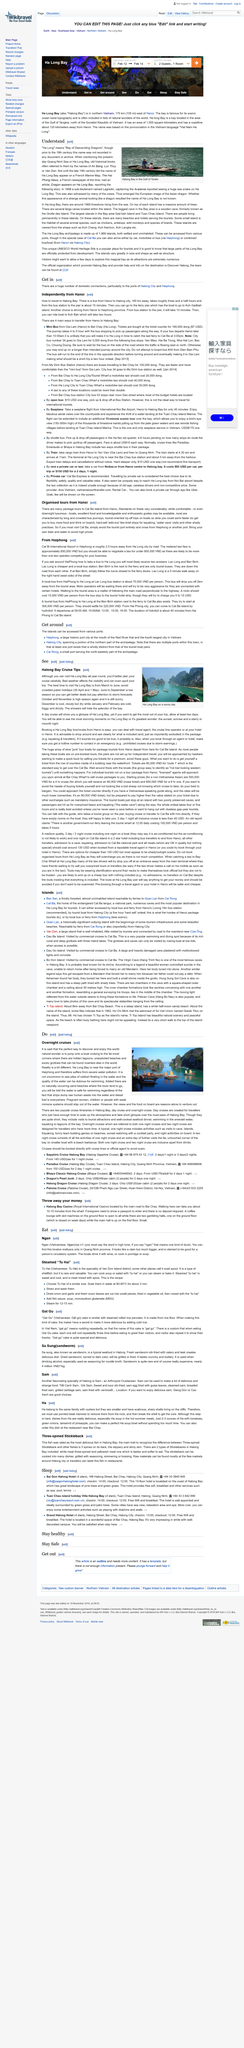Point out several critical features in this image. The top right image was taken in Halong Bay in the Gulf of Tonkin. Ha Long Bay, also known as the Bay of Descending Dragons, is a UNESCO World Heritage Site located in northeastern Vietnam. The name "Ha Long" first appeared in written records in the late 19th century. 